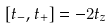Convert formula to latex. <formula><loc_0><loc_0><loc_500><loc_500>[ t _ { - } , t _ { + } ] = - 2 t _ { z }</formula> 